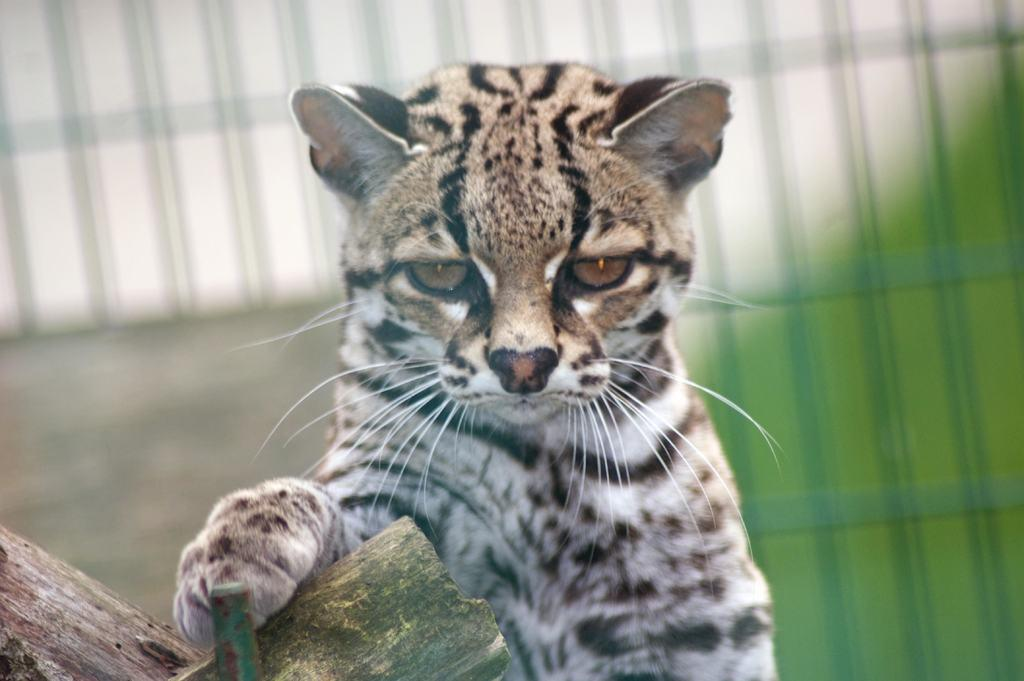What type of animal is in the image? There is an animal in the image, but its specific type cannot be determined from the provided facts. What colors can be seen on the animal? The animal has black, white, and brown colors. What colors are present in the background of the image? The background of the image is green and white. How is the background of the image depicted? The background is blurred. How many trucks are visible in the image? There are no trucks present in the image. What type of snails can be seen in the image? There are no snails present in the image. 